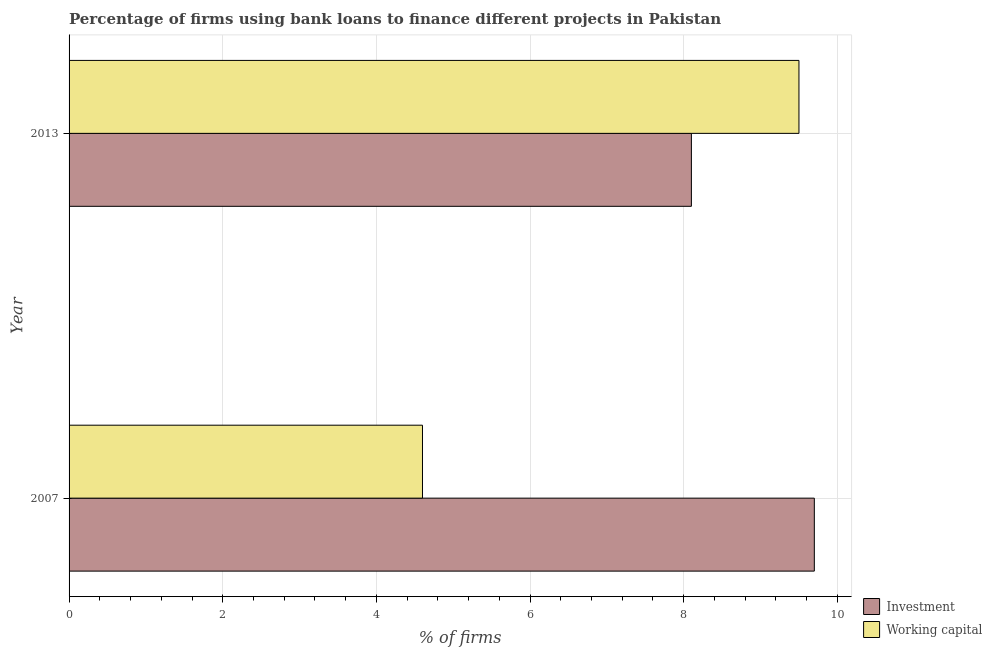How many different coloured bars are there?
Offer a very short reply. 2. How many groups of bars are there?
Your response must be concise. 2. Are the number of bars per tick equal to the number of legend labels?
Give a very brief answer. Yes. How many bars are there on the 1st tick from the top?
Keep it short and to the point. 2. How many bars are there on the 2nd tick from the bottom?
Your response must be concise. 2. In how many cases, is the number of bars for a given year not equal to the number of legend labels?
Make the answer very short. 0. Across all years, what is the minimum percentage of firms using banks to finance investment?
Ensure brevity in your answer.  8.1. What is the total percentage of firms using banks to finance working capital in the graph?
Your answer should be very brief. 14.1. What is the difference between the percentage of firms using banks to finance investment in 2007 and that in 2013?
Offer a terse response. 1.6. What is the difference between the percentage of firms using banks to finance investment in 2013 and the percentage of firms using banks to finance working capital in 2007?
Keep it short and to the point. 3.5. What is the average percentage of firms using banks to finance investment per year?
Give a very brief answer. 8.9. In the year 2013, what is the difference between the percentage of firms using banks to finance investment and percentage of firms using banks to finance working capital?
Provide a short and direct response. -1.4. What is the ratio of the percentage of firms using banks to finance working capital in 2007 to that in 2013?
Ensure brevity in your answer.  0.48. Is the percentage of firms using banks to finance working capital in 2007 less than that in 2013?
Give a very brief answer. Yes. Is the difference between the percentage of firms using banks to finance investment in 2007 and 2013 greater than the difference between the percentage of firms using banks to finance working capital in 2007 and 2013?
Your response must be concise. Yes. What does the 2nd bar from the top in 2007 represents?
Give a very brief answer. Investment. What does the 2nd bar from the bottom in 2007 represents?
Keep it short and to the point. Working capital. Are all the bars in the graph horizontal?
Make the answer very short. Yes. Does the graph contain any zero values?
Your response must be concise. No. Does the graph contain grids?
Make the answer very short. Yes. How are the legend labels stacked?
Ensure brevity in your answer.  Vertical. What is the title of the graph?
Keep it short and to the point. Percentage of firms using bank loans to finance different projects in Pakistan. What is the label or title of the X-axis?
Your response must be concise. % of firms. What is the % of firms of Working capital in 2007?
Offer a terse response. 4.6. What is the % of firms in Investment in 2013?
Your answer should be very brief. 8.1. What is the % of firms of Working capital in 2013?
Ensure brevity in your answer.  9.5. Across all years, what is the minimum % of firms of Investment?
Provide a succinct answer. 8.1. What is the total % of firms of Investment in the graph?
Ensure brevity in your answer.  17.8. What is the total % of firms in Working capital in the graph?
Provide a short and direct response. 14.1. What is the difference between the % of firms in Investment in 2007 and that in 2013?
Give a very brief answer. 1.6. What is the average % of firms of Working capital per year?
Your answer should be very brief. 7.05. In the year 2007, what is the difference between the % of firms in Investment and % of firms in Working capital?
Make the answer very short. 5.1. What is the ratio of the % of firms in Investment in 2007 to that in 2013?
Give a very brief answer. 1.2. What is the ratio of the % of firms of Working capital in 2007 to that in 2013?
Offer a very short reply. 0.48. What is the difference between the highest and the lowest % of firms of Investment?
Provide a succinct answer. 1.6. 